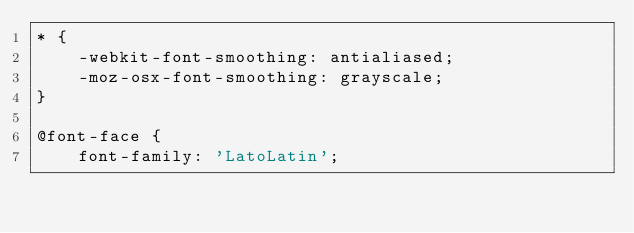<code> <loc_0><loc_0><loc_500><loc_500><_CSS_>* {
	-webkit-font-smoothing: antialiased;
	-moz-osx-font-smoothing: grayscale;
}

@font-face {
    font-family: 'LatoLatin';</code> 